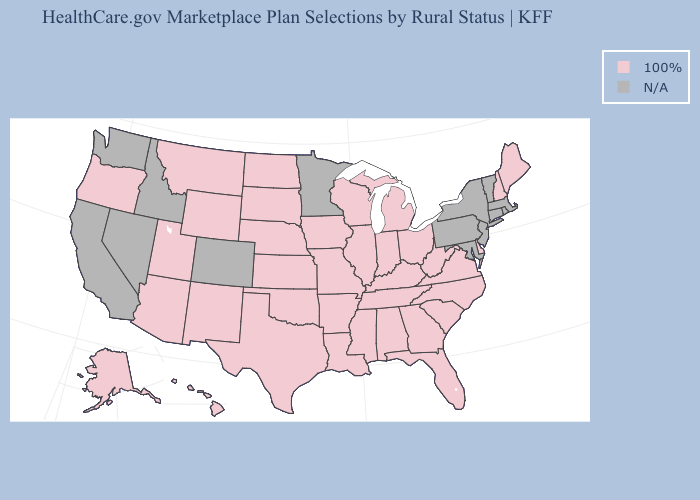Which states have the highest value in the USA?
Write a very short answer. Alabama, Alaska, Arizona, Arkansas, Delaware, Florida, Georgia, Hawaii, Illinois, Indiana, Iowa, Kansas, Kentucky, Louisiana, Maine, Michigan, Mississippi, Missouri, Montana, Nebraska, New Hampshire, New Mexico, North Carolina, North Dakota, Ohio, Oklahoma, Oregon, South Carolina, South Dakota, Tennessee, Texas, Utah, Virginia, West Virginia, Wisconsin, Wyoming. What is the value of Alaska?
Write a very short answer. 100%. Name the states that have a value in the range 100%?
Answer briefly. Alabama, Alaska, Arizona, Arkansas, Delaware, Florida, Georgia, Hawaii, Illinois, Indiana, Iowa, Kansas, Kentucky, Louisiana, Maine, Michigan, Mississippi, Missouri, Montana, Nebraska, New Hampshire, New Mexico, North Carolina, North Dakota, Ohio, Oklahoma, Oregon, South Carolina, South Dakota, Tennessee, Texas, Utah, Virginia, West Virginia, Wisconsin, Wyoming. What is the value of West Virginia?
Short answer required. 100%. What is the lowest value in states that border Massachusetts?
Write a very short answer. 100%. Name the states that have a value in the range N/A?
Quick response, please. California, Colorado, Connecticut, Idaho, Maryland, Massachusetts, Minnesota, Nevada, New Jersey, New York, Pennsylvania, Rhode Island, Vermont, Washington. Name the states that have a value in the range 100%?
Answer briefly. Alabama, Alaska, Arizona, Arkansas, Delaware, Florida, Georgia, Hawaii, Illinois, Indiana, Iowa, Kansas, Kentucky, Louisiana, Maine, Michigan, Mississippi, Missouri, Montana, Nebraska, New Hampshire, New Mexico, North Carolina, North Dakota, Ohio, Oklahoma, Oregon, South Carolina, South Dakota, Tennessee, Texas, Utah, Virginia, West Virginia, Wisconsin, Wyoming. What is the value of Nevada?
Answer briefly. N/A. Name the states that have a value in the range 100%?
Write a very short answer. Alabama, Alaska, Arizona, Arkansas, Delaware, Florida, Georgia, Hawaii, Illinois, Indiana, Iowa, Kansas, Kentucky, Louisiana, Maine, Michigan, Mississippi, Missouri, Montana, Nebraska, New Hampshire, New Mexico, North Carolina, North Dakota, Ohio, Oklahoma, Oregon, South Carolina, South Dakota, Tennessee, Texas, Utah, Virginia, West Virginia, Wisconsin, Wyoming. Name the states that have a value in the range 100%?
Answer briefly. Alabama, Alaska, Arizona, Arkansas, Delaware, Florida, Georgia, Hawaii, Illinois, Indiana, Iowa, Kansas, Kentucky, Louisiana, Maine, Michigan, Mississippi, Missouri, Montana, Nebraska, New Hampshire, New Mexico, North Carolina, North Dakota, Ohio, Oklahoma, Oregon, South Carolina, South Dakota, Tennessee, Texas, Utah, Virginia, West Virginia, Wisconsin, Wyoming. Which states have the lowest value in the MidWest?
Be succinct. Illinois, Indiana, Iowa, Kansas, Michigan, Missouri, Nebraska, North Dakota, Ohio, South Dakota, Wisconsin. Which states have the highest value in the USA?
Quick response, please. Alabama, Alaska, Arizona, Arkansas, Delaware, Florida, Georgia, Hawaii, Illinois, Indiana, Iowa, Kansas, Kentucky, Louisiana, Maine, Michigan, Mississippi, Missouri, Montana, Nebraska, New Hampshire, New Mexico, North Carolina, North Dakota, Ohio, Oklahoma, Oregon, South Carolina, South Dakota, Tennessee, Texas, Utah, Virginia, West Virginia, Wisconsin, Wyoming. 